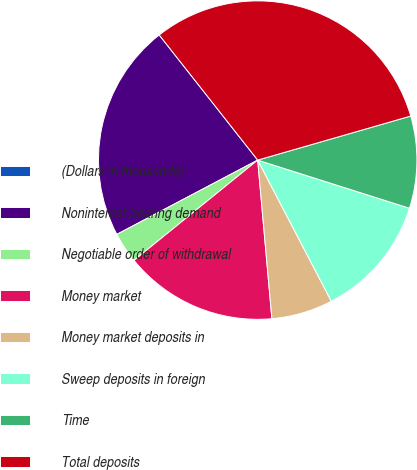Convert chart. <chart><loc_0><loc_0><loc_500><loc_500><pie_chart><fcel>(Dollars in thousands)<fcel>Noninterest-bearing demand<fcel>Negotiable order of withdrawal<fcel>Money market<fcel>Money market deposits in<fcel>Sweep deposits in foreign<fcel>Time<fcel>Total deposits<nl><fcel>0.0%<fcel>22.11%<fcel>3.12%<fcel>15.58%<fcel>6.23%<fcel>12.46%<fcel>9.35%<fcel>31.15%<nl></chart> 